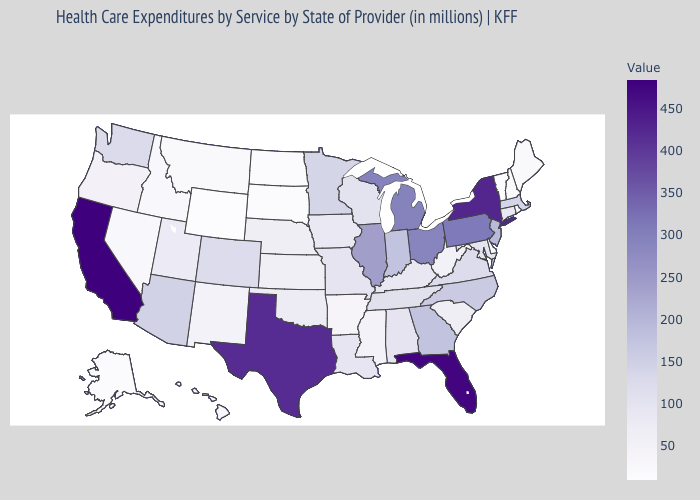Does Missouri have the lowest value in the MidWest?
Answer briefly. No. Which states have the lowest value in the Northeast?
Be succinct. Vermont. Which states have the lowest value in the USA?
Give a very brief answer. Vermont. Does Vermont have the lowest value in the USA?
Quick response, please. Yes. Among the states that border Washington , which have the lowest value?
Keep it brief. Idaho. 